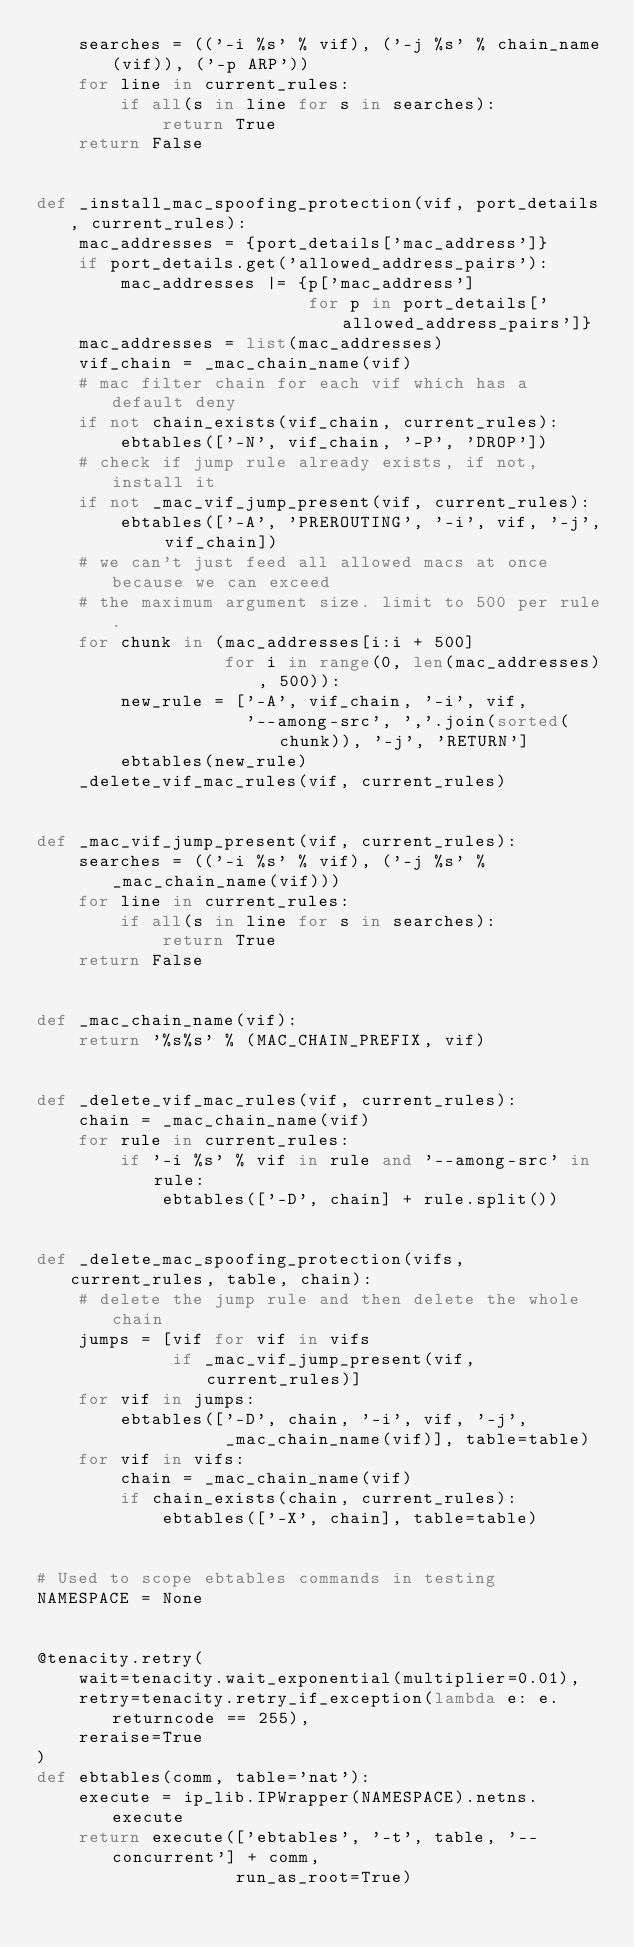<code> <loc_0><loc_0><loc_500><loc_500><_Python_>    searches = (('-i %s' % vif), ('-j %s' % chain_name(vif)), ('-p ARP'))
    for line in current_rules:
        if all(s in line for s in searches):
            return True
    return False


def _install_mac_spoofing_protection(vif, port_details, current_rules):
    mac_addresses = {port_details['mac_address']}
    if port_details.get('allowed_address_pairs'):
        mac_addresses |= {p['mac_address']
                          for p in port_details['allowed_address_pairs']}
    mac_addresses = list(mac_addresses)
    vif_chain = _mac_chain_name(vif)
    # mac filter chain for each vif which has a default deny
    if not chain_exists(vif_chain, current_rules):
        ebtables(['-N', vif_chain, '-P', 'DROP'])
    # check if jump rule already exists, if not, install it
    if not _mac_vif_jump_present(vif, current_rules):
        ebtables(['-A', 'PREROUTING', '-i', vif, '-j', vif_chain])
    # we can't just feed all allowed macs at once because we can exceed
    # the maximum argument size. limit to 500 per rule.
    for chunk in (mac_addresses[i:i + 500]
                  for i in range(0, len(mac_addresses), 500)):
        new_rule = ['-A', vif_chain, '-i', vif,
                    '--among-src', ','.join(sorted(chunk)), '-j', 'RETURN']
        ebtables(new_rule)
    _delete_vif_mac_rules(vif, current_rules)


def _mac_vif_jump_present(vif, current_rules):
    searches = (('-i %s' % vif), ('-j %s' % _mac_chain_name(vif)))
    for line in current_rules:
        if all(s in line for s in searches):
            return True
    return False


def _mac_chain_name(vif):
    return '%s%s' % (MAC_CHAIN_PREFIX, vif)


def _delete_vif_mac_rules(vif, current_rules):
    chain = _mac_chain_name(vif)
    for rule in current_rules:
        if '-i %s' % vif in rule and '--among-src' in rule:
            ebtables(['-D', chain] + rule.split())


def _delete_mac_spoofing_protection(vifs, current_rules, table, chain):
    # delete the jump rule and then delete the whole chain
    jumps = [vif for vif in vifs
             if _mac_vif_jump_present(vif, current_rules)]
    for vif in jumps:
        ebtables(['-D', chain, '-i', vif, '-j',
                  _mac_chain_name(vif)], table=table)
    for vif in vifs:
        chain = _mac_chain_name(vif)
        if chain_exists(chain, current_rules):
            ebtables(['-X', chain], table=table)


# Used to scope ebtables commands in testing
NAMESPACE = None


@tenacity.retry(
    wait=tenacity.wait_exponential(multiplier=0.01),
    retry=tenacity.retry_if_exception(lambda e: e.returncode == 255),
    reraise=True
)
def ebtables(comm, table='nat'):
    execute = ip_lib.IPWrapper(NAMESPACE).netns.execute
    return execute(['ebtables', '-t', table, '--concurrent'] + comm,
                   run_as_root=True)
</code> 